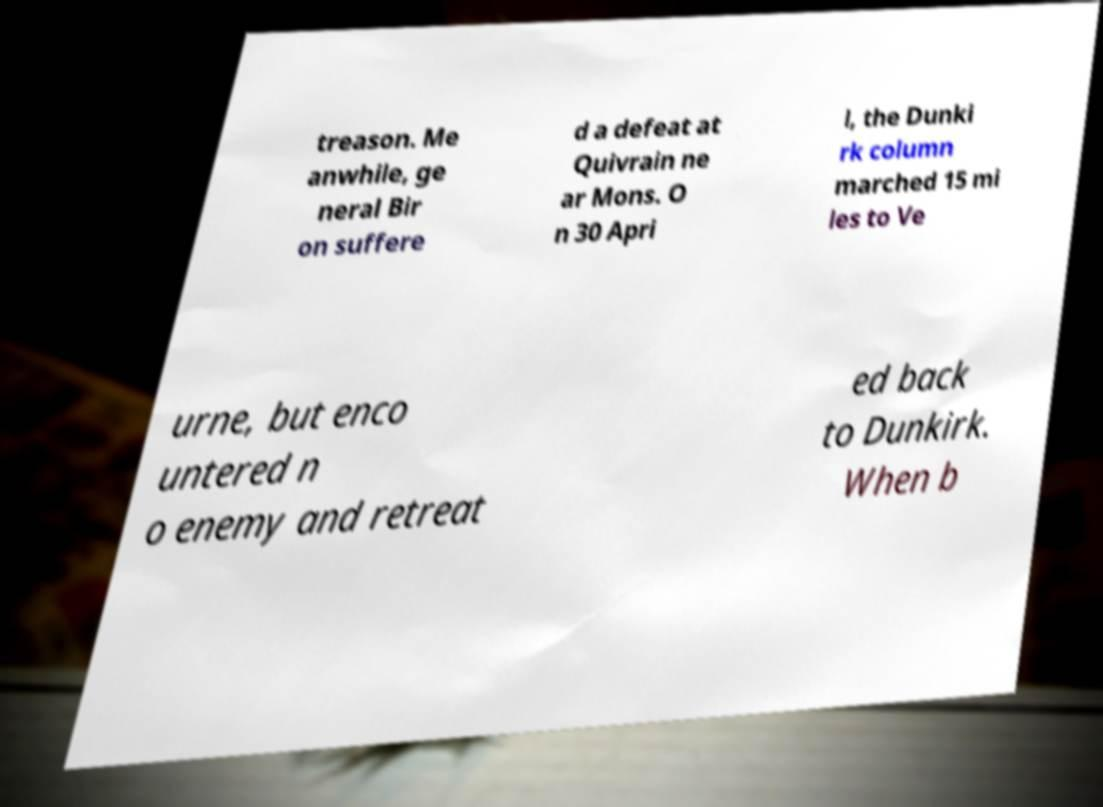Please identify and transcribe the text found in this image. treason. Me anwhile, ge neral Bir on suffere d a defeat at Quivrain ne ar Mons. O n 30 Apri l, the Dunki rk column marched 15 mi les to Ve urne, but enco untered n o enemy and retreat ed back to Dunkirk. When b 